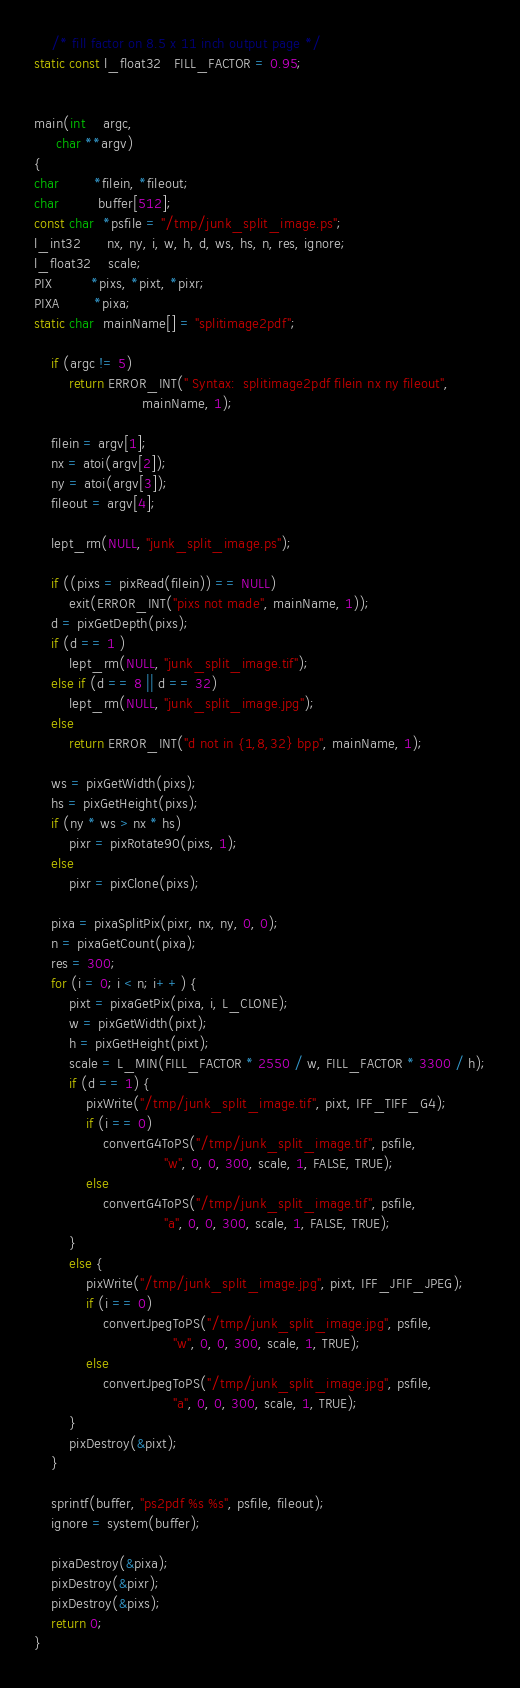Convert code to text. <code><loc_0><loc_0><loc_500><loc_500><_C_>    /* fill factor on 8.5 x 11 inch output page */
static const l_float32   FILL_FACTOR = 0.95;


main(int    argc,
     char **argv)
{
char        *filein, *fileout;
char         buffer[512];
const char  *psfile = "/tmp/junk_split_image.ps";
l_int32      nx, ny, i, w, h, d, ws, hs, n, res, ignore;
l_float32    scale;
PIX         *pixs, *pixt, *pixr;
PIXA        *pixa;
static char  mainName[] = "splitimage2pdf";

    if (argc != 5)
        return ERROR_INT(" Syntax:  splitimage2pdf filein nx ny fileout",
                         mainName, 1);

    filein = argv[1];
    nx = atoi(argv[2]);
    ny = atoi(argv[3]);
    fileout = argv[4];

    lept_rm(NULL, "junk_split_image.ps");

    if ((pixs = pixRead(filein)) == NULL)
        exit(ERROR_INT("pixs not made", mainName, 1));
    d = pixGetDepth(pixs);
    if (d == 1 )
        lept_rm(NULL, "junk_split_image.tif");
    else if (d == 8 || d == 32)
        lept_rm(NULL, "junk_split_image.jpg");
    else
        return ERROR_INT("d not in {1,8,32} bpp", mainName, 1);

    ws = pixGetWidth(pixs);
    hs = pixGetHeight(pixs);
    if (ny * ws > nx * hs)
        pixr = pixRotate90(pixs, 1);
    else
        pixr = pixClone(pixs);

    pixa = pixaSplitPix(pixr, nx, ny, 0, 0);
    n = pixaGetCount(pixa);
    res = 300;
    for (i = 0; i < n; i++) {
        pixt = pixaGetPix(pixa, i, L_CLONE);
        w = pixGetWidth(pixt);
        h = pixGetHeight(pixt);
        scale = L_MIN(FILL_FACTOR * 2550 / w, FILL_FACTOR * 3300 / h);
        if (d == 1) {
            pixWrite("/tmp/junk_split_image.tif", pixt, IFF_TIFF_G4);
            if (i == 0)
                convertG4ToPS("/tmp/junk_split_image.tif", psfile,
                              "w", 0, 0, 300, scale, 1, FALSE, TRUE);
            else
                convertG4ToPS("/tmp/junk_split_image.tif", psfile,
                              "a", 0, 0, 300, scale, 1, FALSE, TRUE);
        }
        else {
            pixWrite("/tmp/junk_split_image.jpg", pixt, IFF_JFIF_JPEG);
            if (i == 0)
                convertJpegToPS("/tmp/junk_split_image.jpg", psfile,
                                "w", 0, 0, 300, scale, 1, TRUE);
            else
                convertJpegToPS("/tmp/junk_split_image.jpg", psfile,
                                "a", 0, 0, 300, scale, 1, TRUE);
        }
        pixDestroy(&pixt);
    }

    sprintf(buffer, "ps2pdf %s %s", psfile, fileout);
    ignore = system(buffer);

    pixaDestroy(&pixa);
    pixDestroy(&pixr);
    pixDestroy(&pixs);
    return 0;
}

</code> 